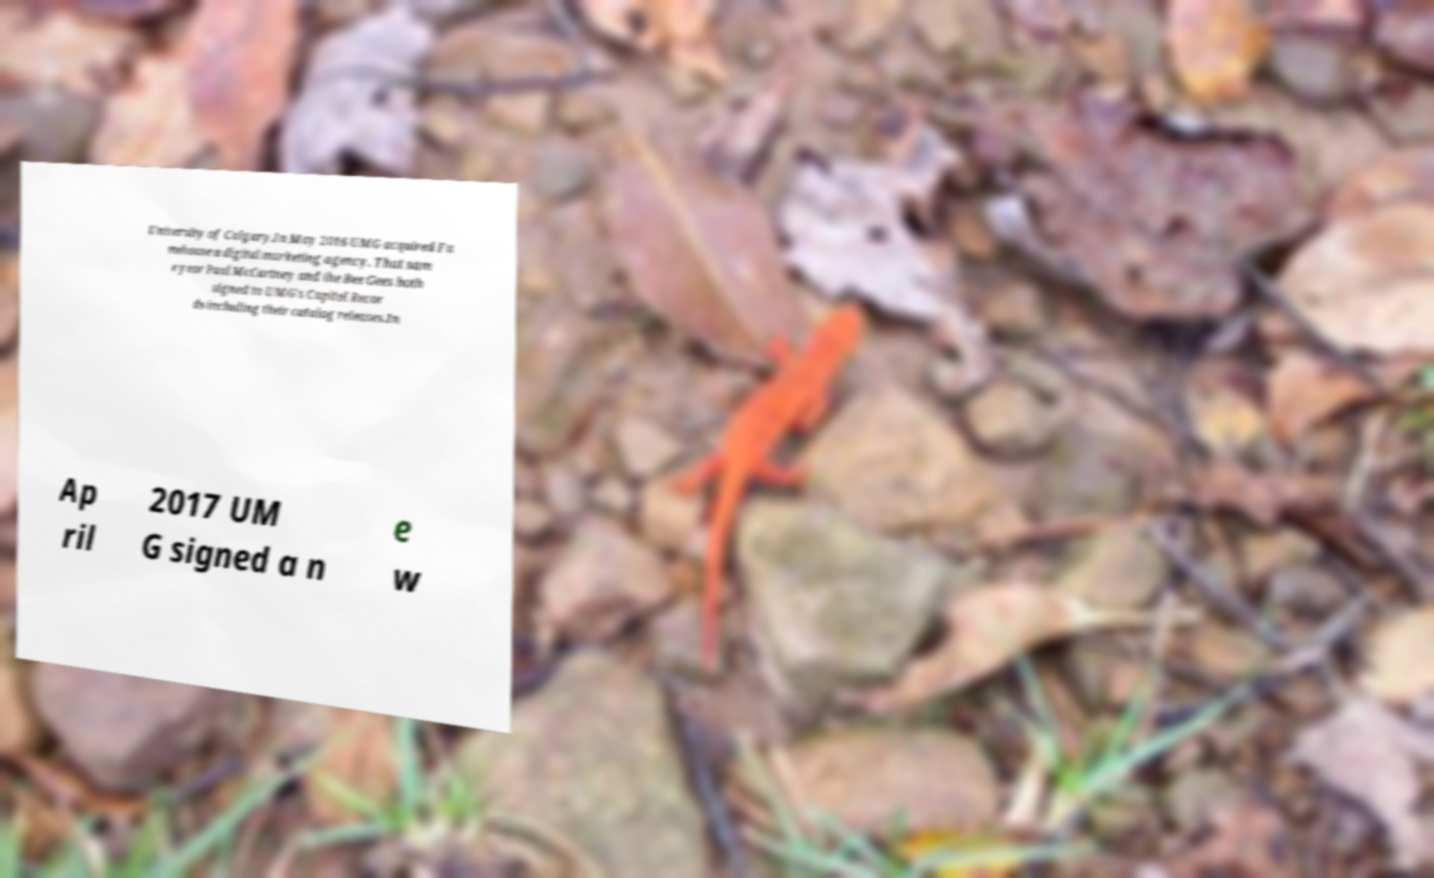Please read and relay the text visible in this image. What does it say? University of Calgary.In May 2016 UMG acquired Fa mehouse a digital marketing agency. That sam e year Paul McCartney and the Bee Gees both signed to UMG's Capitol Recor ds including their catalog releases.In Ap ril 2017 UM G signed a n e w 